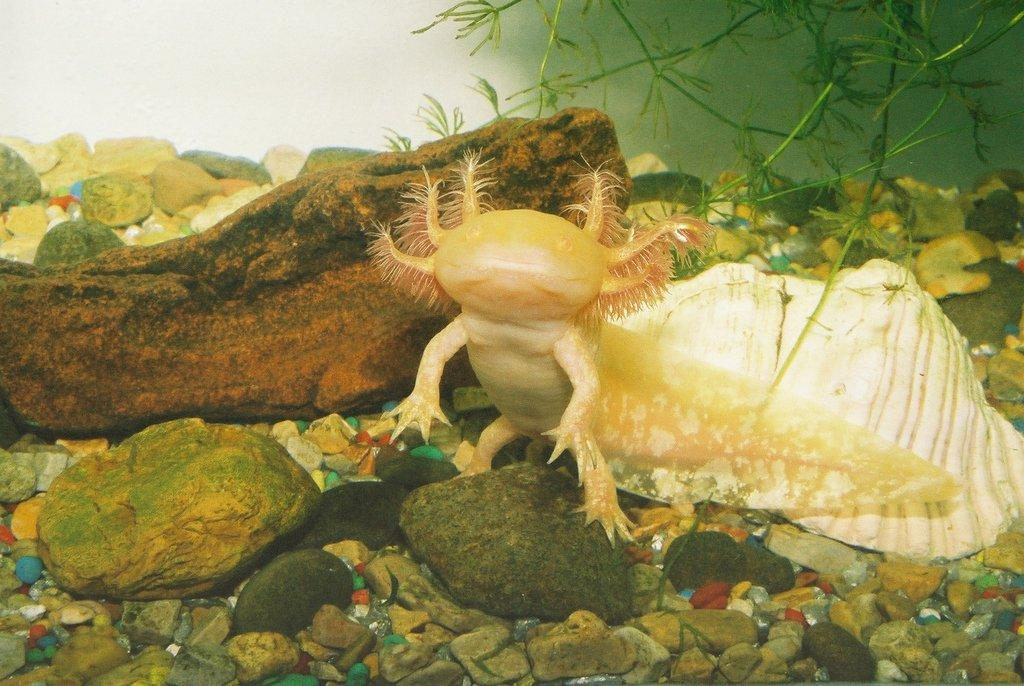What is the main subject of the image? The main subject of the image is an inside view of water. What objects can be seen in the water? There are stones, a shell, and other marine species present in the image. Is there any vegetation visible in the image? Yes, there is a plant in the image. What type of stew is being served on the tray in the image? There is no tray or stew present in the image; it is an inside view of water with stones, a shell, a plant, and other marine species. 